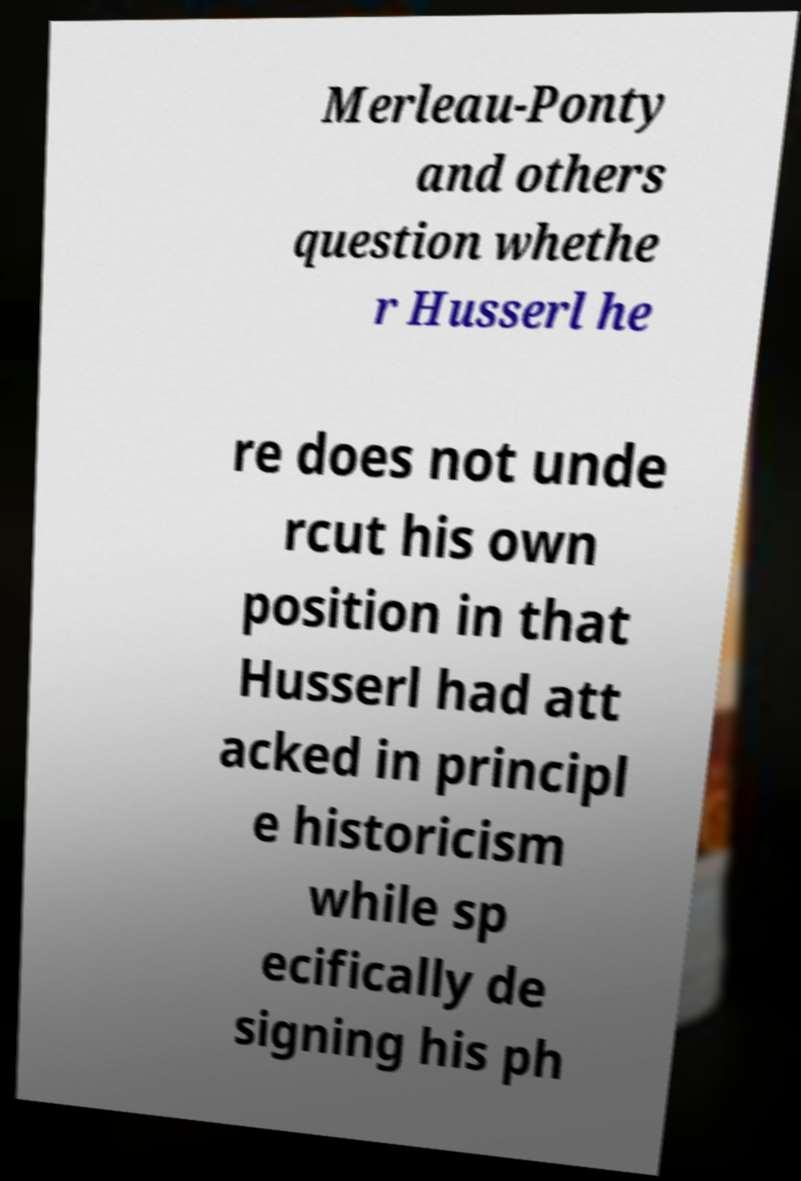Please read and relay the text visible in this image. What does it say? Merleau-Ponty and others question whethe r Husserl he re does not unde rcut his own position in that Husserl had att acked in principl e historicism while sp ecifically de signing his ph 